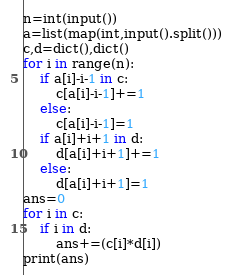Convert code to text. <code><loc_0><loc_0><loc_500><loc_500><_Python_>n=int(input())
a=list(map(int,input().split()))
c,d=dict(),dict()
for i in range(n):
    if a[i]-i-1 in c:
        c[a[i]-i-1]+=1
    else:
        c[a[i]-i-1]=1
    if a[i]+i+1 in d:
        d[a[i]+i+1]+=1
    else:
        d[a[i]+i+1]=1
ans=0
for i in c:
    if i in d:
        ans+=(c[i]*d[i])
print(ans)
</code> 